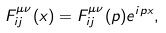Convert formula to latex. <formula><loc_0><loc_0><loc_500><loc_500>F ^ { \mu \nu } _ { i j } ( x ) = F ^ { \mu \nu } _ { i j } ( p ) e ^ { i p x } ,</formula> 